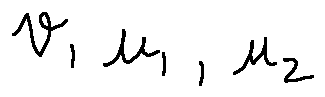<formula> <loc_0><loc_0><loc_500><loc_500>v , u _ { 1 } , u _ { 2 }</formula> 